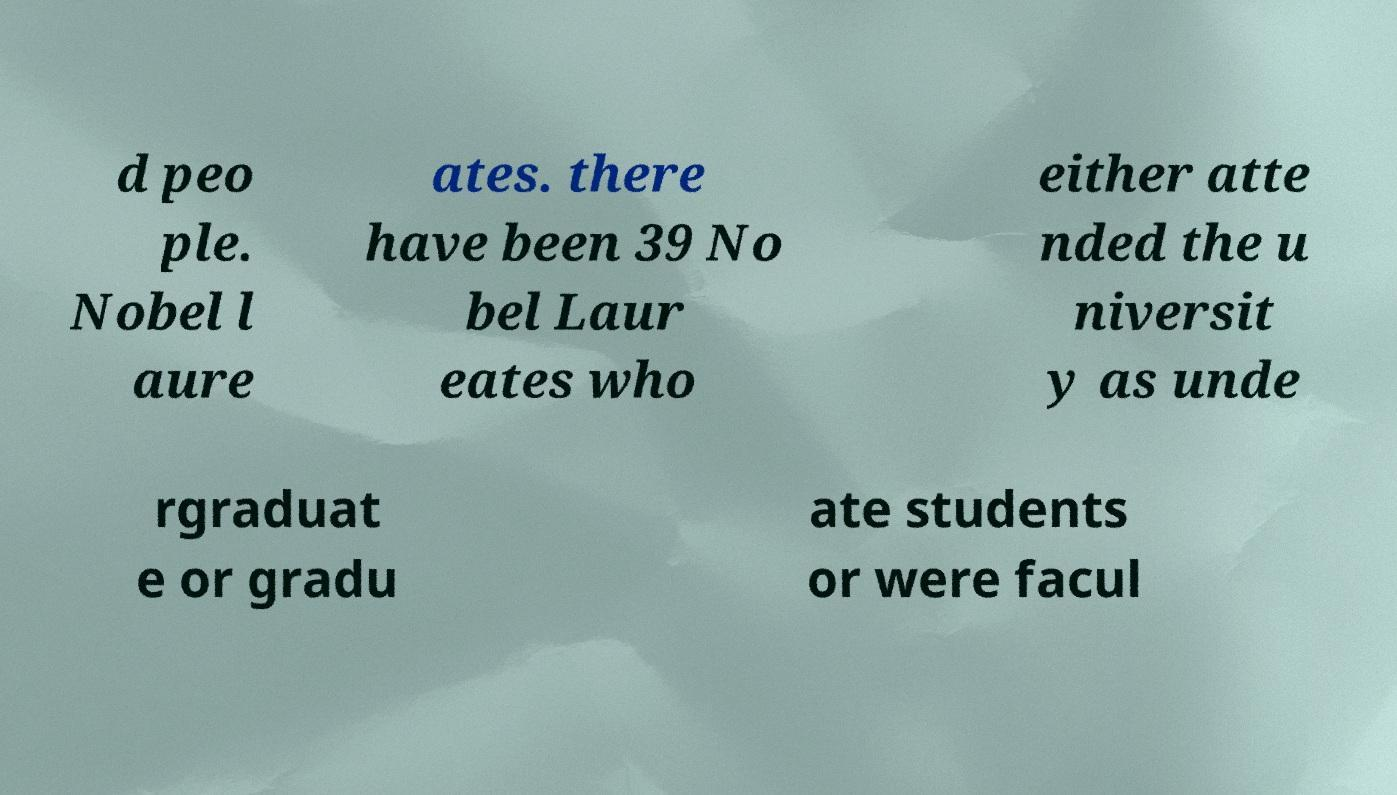There's text embedded in this image that I need extracted. Can you transcribe it verbatim? d peo ple. Nobel l aure ates. there have been 39 No bel Laur eates who either atte nded the u niversit y as unde rgraduat e or gradu ate students or were facul 